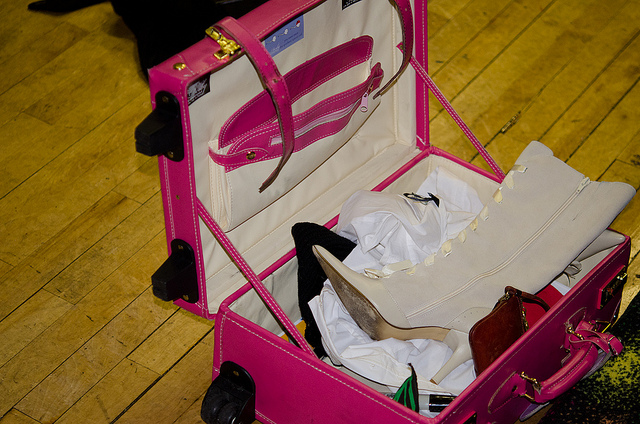<image>What shade of blue is that luggage? The luggage is not blue. It might be pink or purple. What shade of blue is that luggage? It is unknown what shade of blue the luggage is. However, it can be seen pink. 